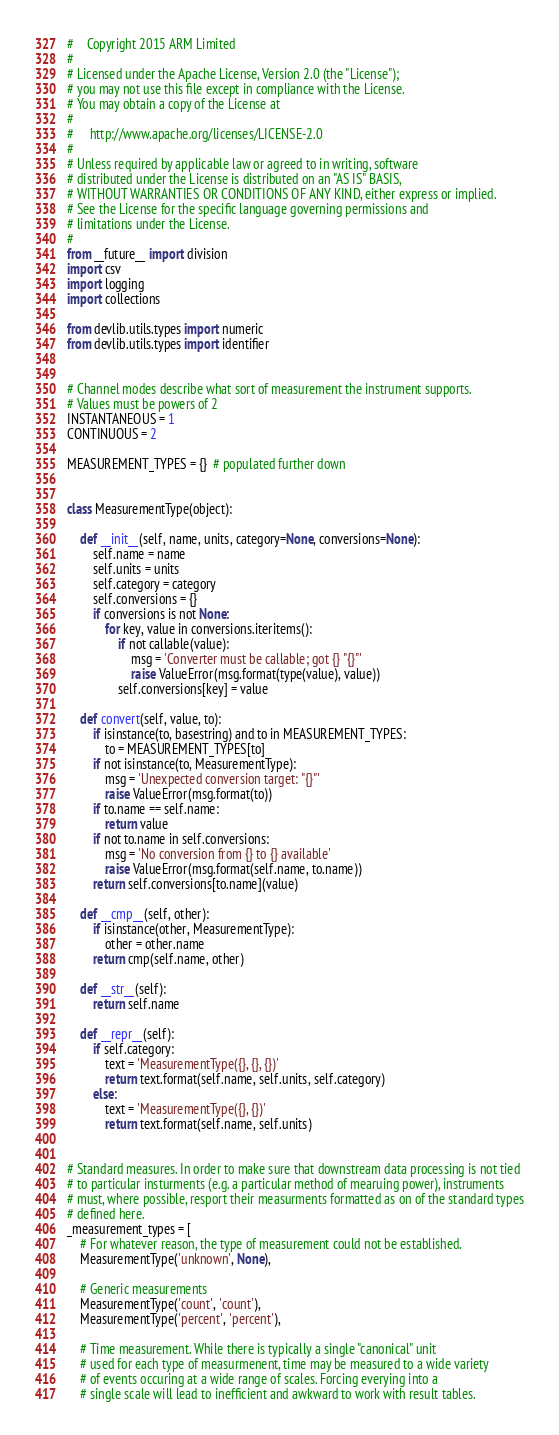Convert code to text. <code><loc_0><loc_0><loc_500><loc_500><_Python_>#    Copyright 2015 ARM Limited
#
# Licensed under the Apache License, Version 2.0 (the "License");
# you may not use this file except in compliance with the License.
# You may obtain a copy of the License at
#
#     http://www.apache.org/licenses/LICENSE-2.0
#
# Unless required by applicable law or agreed to in writing, software
# distributed under the License is distributed on an "AS IS" BASIS,
# WITHOUT WARRANTIES OR CONDITIONS OF ANY KIND, either express or implied.
# See the License for the specific language governing permissions and
# limitations under the License.
#
from __future__ import division
import csv
import logging
import collections

from devlib.utils.types import numeric
from devlib.utils.types import identifier


# Channel modes describe what sort of measurement the instrument supports.
# Values must be powers of 2
INSTANTANEOUS = 1
CONTINUOUS = 2

MEASUREMENT_TYPES = {}  # populated further down


class MeasurementType(object):

    def __init__(self, name, units, category=None, conversions=None):
        self.name = name
        self.units = units
        self.category = category
        self.conversions = {}
        if conversions is not None:
            for key, value in conversions.iteritems():
                if not callable(value):
                    msg = 'Converter must be callable; got {} "{}"'
                    raise ValueError(msg.format(type(value), value))
                self.conversions[key] = value

    def convert(self, value, to):
        if isinstance(to, basestring) and to in MEASUREMENT_TYPES:
            to = MEASUREMENT_TYPES[to]
        if not isinstance(to, MeasurementType):
            msg = 'Unexpected conversion target: "{}"'
            raise ValueError(msg.format(to))
        if to.name == self.name:
            return value
        if not to.name in self.conversions:
            msg = 'No conversion from {} to {} available'
            raise ValueError(msg.format(self.name, to.name))
        return self.conversions[to.name](value)

    def __cmp__(self, other):
        if isinstance(other, MeasurementType):
            other = other.name
        return cmp(self.name, other)

    def __str__(self):
        return self.name

    def __repr__(self):
        if self.category:
            text = 'MeasurementType({}, {}, {})'
            return text.format(self.name, self.units, self.category)
        else:
            text = 'MeasurementType({}, {})'
            return text.format(self.name, self.units)


# Standard measures. In order to make sure that downstream data processing is not tied
# to particular insturments (e.g. a particular method of mearuing power), instruments
# must, where possible, resport their measurments formatted as on of the standard types
# defined here.
_measurement_types = [
    # For whatever reason, the type of measurement could not be established.
    MeasurementType('unknown', None),

    # Generic measurements
    MeasurementType('count', 'count'),
    MeasurementType('percent', 'percent'),

    # Time measurement. While there is typically a single "canonical" unit
    # used for each type of measurmenent, time may be measured to a wide variety
    # of events occuring at a wide range of scales. Forcing everying into a
    # single scale will lead to inefficient and awkward to work with result tables.</code> 